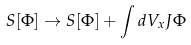<formula> <loc_0><loc_0><loc_500><loc_500>S [ \Phi ] \rightarrow S [ \Phi ] + \int d V _ { x } J \Phi</formula> 